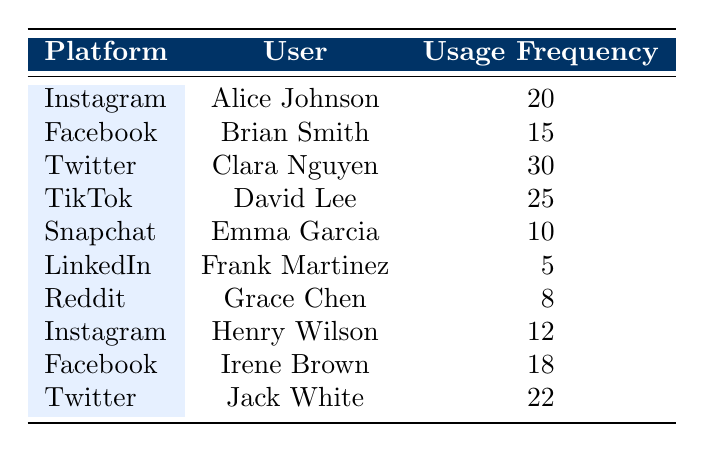What is the usage frequency of Clara Nguyen on Twitter? From the table, we can directly refer to the row that lists Clara Nguyen's usage frequency under the Twitter platform. It shows a usage frequency of 30.
Answer: 30 Which platform has the highest usage frequency, and what is that frequency? By analyzing the usage frequency values in each row, Twitter has the highest frequency at 30.
Answer: Twitter, 30 What is the total usage frequency for Instagram users? To calculate the total, we look for all users who use Instagram, which are Alice Johnson (20) and Henry Wilson (12). The total is 20 + 12 = 32.
Answer: 32 Is Frank Martinez the only user with a usage frequency of less than 10? In the table, Frank Martinez has a usage frequency of 5, but we also need to check if there are other users with frequencies less than 10. Grace Chen has 8, so the statement is false.
Answer: No What is the average usage frequency among the users listed? First, we need to sum all the usage frequencies (20 + 15 + 30 + 25 + 10 + 5 + 8 + 12 + 18 + 22) =  20 + 15 + 30 + 25 + 10 + 5 + 8 + 12 + 18 + 22 =  20 + 15 = 35 + 30 = 65 + 25 = 90 + 10 = 100 + 5 = 105 + 8 = 113 + 12 = 125 + 18 = 143 + 22 = 165. There are 10 users, so the average is 165 / 10 = 16.5.
Answer: 16.5 How many users have a usage frequency of more than 20? By examining the table, the users with frequencies higher than 20 are Clara Nguyen (30), David Lee (25), and Jack White (22). Therefore, there are three users with usage frequency higher than 20.
Answer: 3 